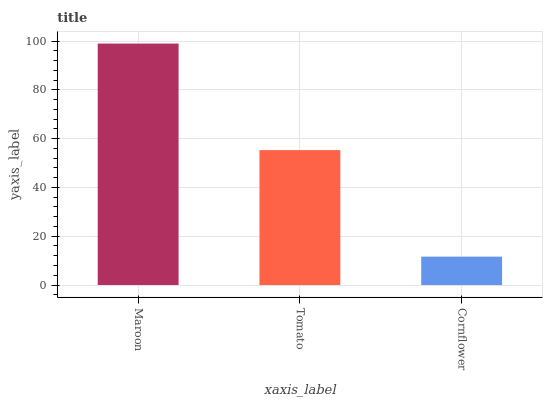Is Cornflower the minimum?
Answer yes or no. Yes. Is Maroon the maximum?
Answer yes or no. Yes. Is Tomato the minimum?
Answer yes or no. No. Is Tomato the maximum?
Answer yes or no. No. Is Maroon greater than Tomato?
Answer yes or no. Yes. Is Tomato less than Maroon?
Answer yes or no. Yes. Is Tomato greater than Maroon?
Answer yes or no. No. Is Maroon less than Tomato?
Answer yes or no. No. Is Tomato the high median?
Answer yes or no. Yes. Is Tomato the low median?
Answer yes or no. Yes. Is Cornflower the high median?
Answer yes or no. No. Is Maroon the low median?
Answer yes or no. No. 